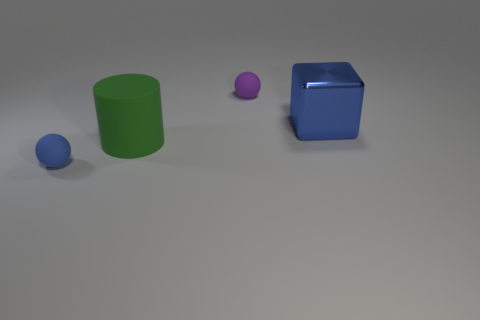Subtract 1 cylinders. How many cylinders are left? 0 Add 2 large red rubber blocks. How many objects exist? 6 Subtract all blue balls. How many balls are left? 1 Subtract all cylinders. How many objects are left? 3 Subtract 0 brown spheres. How many objects are left? 4 Subtract all yellow cylinders. Subtract all red balls. How many cylinders are left? 1 Subtract all big blocks. Subtract all big green cylinders. How many objects are left? 2 Add 3 green things. How many green things are left? 4 Add 2 green cylinders. How many green cylinders exist? 3 